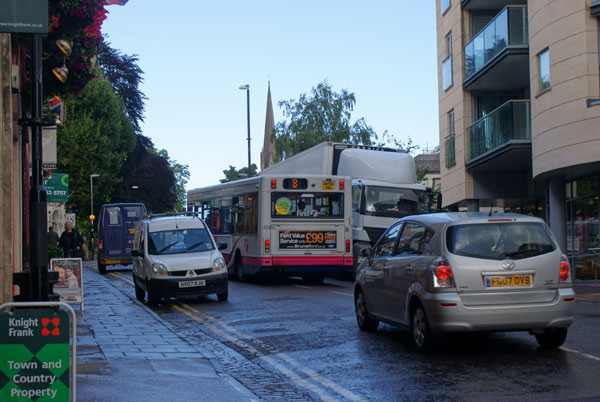Read and extract the text from this image. property Town Country 8 99 and Frank Knight 